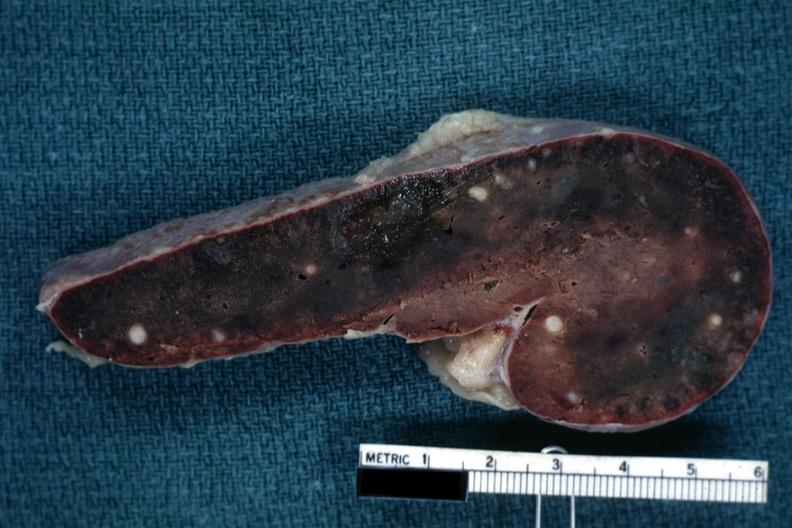what does this image show?
Answer the question using a single word or phrase. Fixed tissue cut surface congested parenchyma with obvious granulomas 